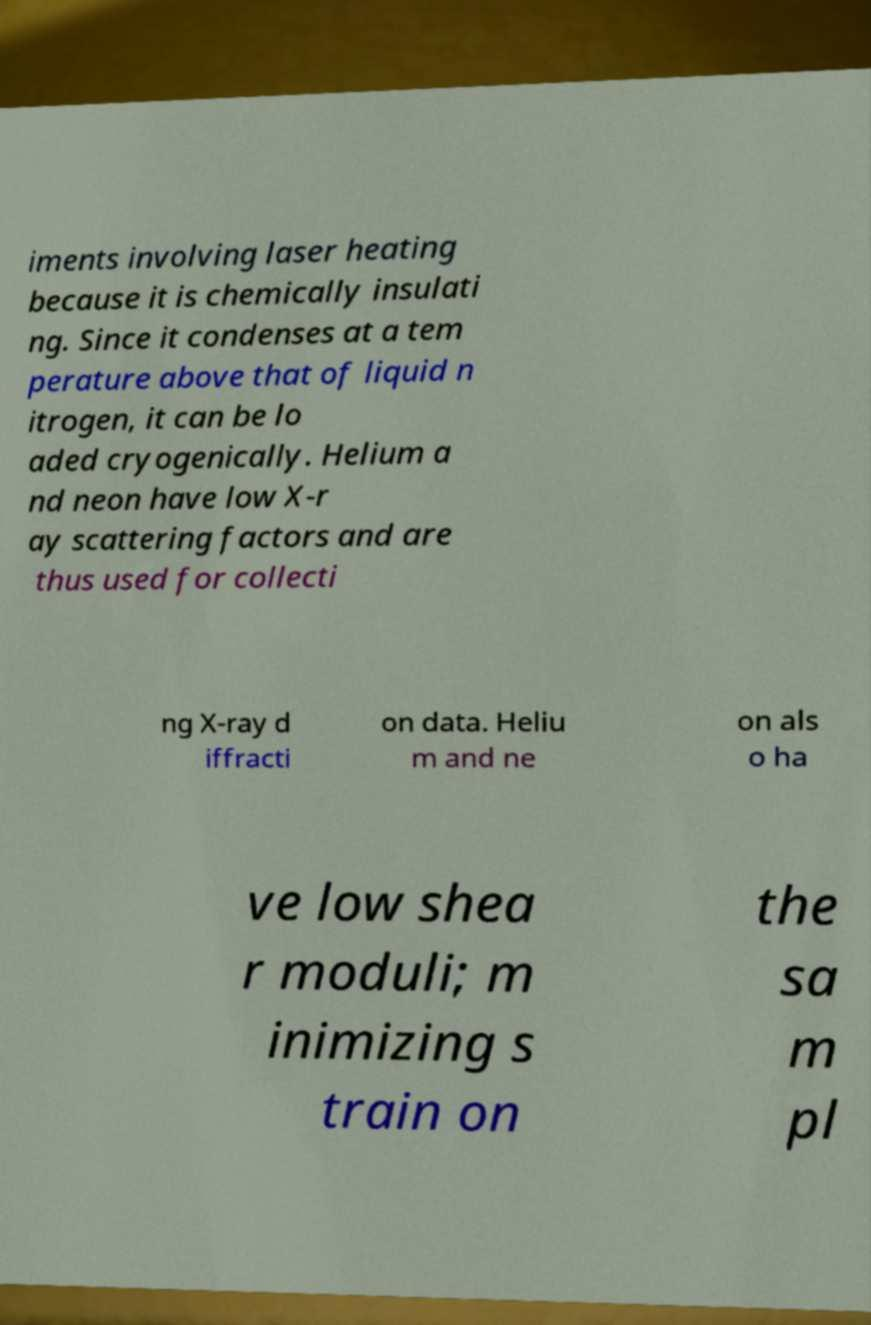Could you extract and type out the text from this image? iments involving laser heating because it is chemically insulati ng. Since it condenses at a tem perature above that of liquid n itrogen, it can be lo aded cryogenically. Helium a nd neon have low X-r ay scattering factors and are thus used for collecti ng X-ray d iffracti on data. Heliu m and ne on als o ha ve low shea r moduli; m inimizing s train on the sa m pl 